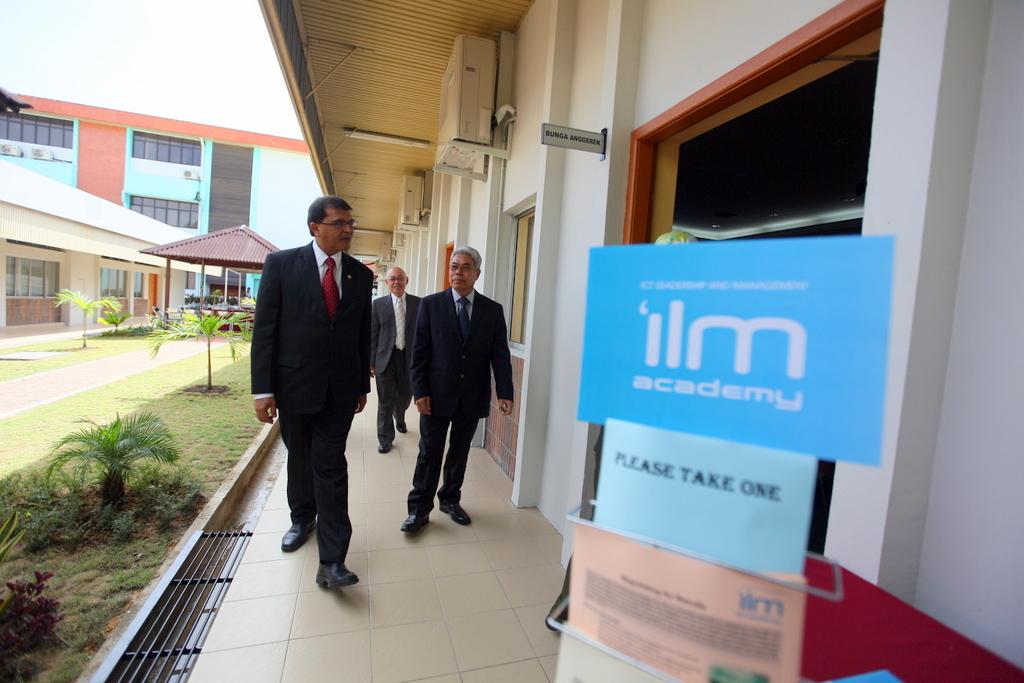At which school is this photo taken?
Make the answer very short. Ilm academy. 